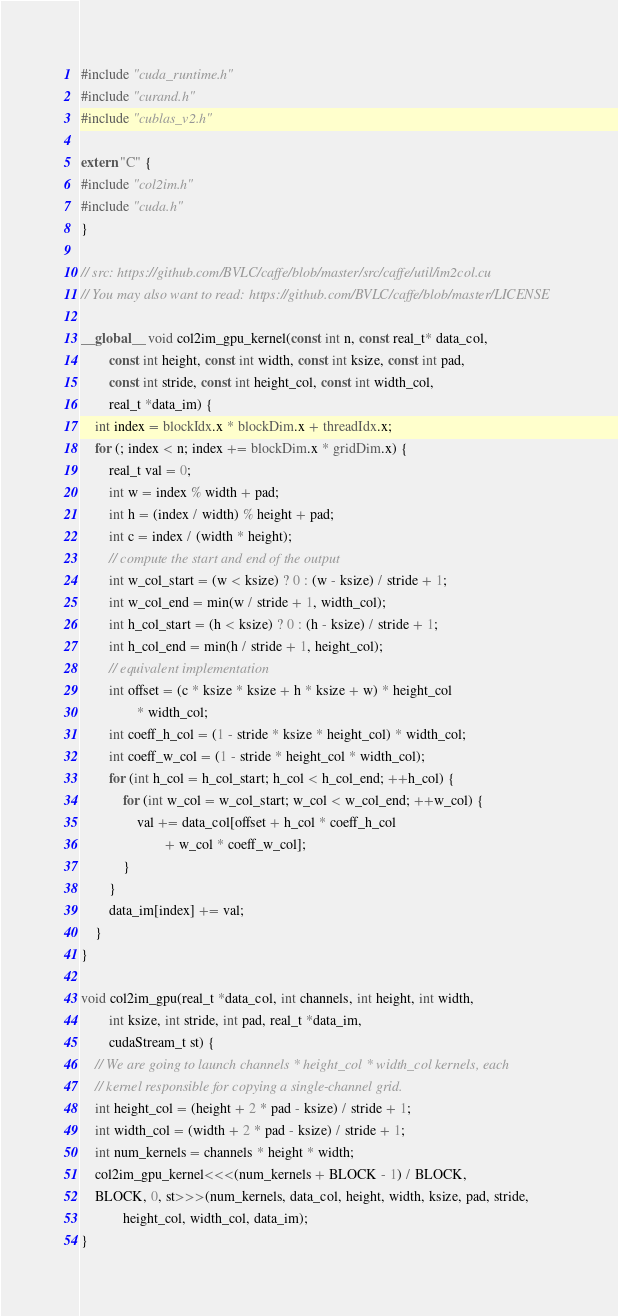<code> <loc_0><loc_0><loc_500><loc_500><_Cuda_>#include "cuda_runtime.h"
#include "curand.h"
#include "cublas_v2.h"

extern "C" {
#include "col2im.h"
#include "cuda.h"
}

// src: https://github.com/BVLC/caffe/blob/master/src/caffe/util/im2col.cu
// You may also want to read: https://github.com/BVLC/caffe/blob/master/LICENSE

__global__ void col2im_gpu_kernel(const int n, const real_t* data_col,
		const int height, const int width, const int ksize, const int pad,
		const int stride, const int height_col, const int width_col,
		real_t *data_im) {
	int index = blockIdx.x * blockDim.x + threadIdx.x;
	for (; index < n; index += blockDim.x * gridDim.x) {
		real_t val = 0;
		int w = index % width + pad;
		int h = (index / width) % height + pad;
		int c = index / (width * height);
		// compute the start and end of the output
		int w_col_start = (w < ksize) ? 0 : (w - ksize) / stride + 1;
		int w_col_end = min(w / stride + 1, width_col);
		int h_col_start = (h < ksize) ? 0 : (h - ksize) / stride + 1;
		int h_col_end = min(h / stride + 1, height_col);
		// equivalent implementation
		int offset = (c * ksize * ksize + h * ksize + w) * height_col
				* width_col;
		int coeff_h_col = (1 - stride * ksize * height_col) * width_col;
		int coeff_w_col = (1 - stride * height_col * width_col);
		for (int h_col = h_col_start; h_col < h_col_end; ++h_col) {
			for (int w_col = w_col_start; w_col < w_col_end; ++w_col) {
				val += data_col[offset + h_col * coeff_h_col
						+ w_col * coeff_w_col];
			}
		}
		data_im[index] += val;
	}
}

void col2im_gpu(real_t *data_col, int channels, int height, int width,
		int ksize, int stride, int pad, real_t *data_im,
		cudaStream_t st) {
	// We are going to launch channels * height_col * width_col kernels, each
	// kernel responsible for copying a single-channel grid.
	int height_col = (height + 2 * pad - ksize) / stride + 1;
	int width_col = (width + 2 * pad - ksize) / stride + 1;
	int num_kernels = channels * height * width;
	col2im_gpu_kernel<<<(num_kernels + BLOCK - 1) / BLOCK,
	BLOCK, 0, st>>>(num_kernels, data_col, height, width, ksize, pad, stride,
			height_col, width_col, data_im);
}

</code> 